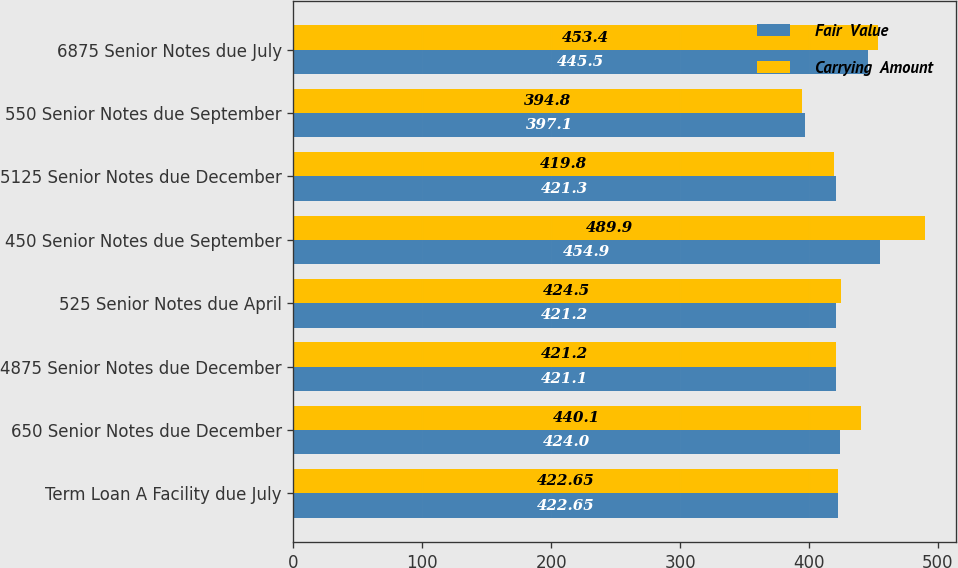Convert chart to OTSL. <chart><loc_0><loc_0><loc_500><loc_500><stacked_bar_chart><ecel><fcel>Term Loan A Facility due July<fcel>650 Senior Notes due December<fcel>4875 Senior Notes due December<fcel>525 Senior Notes due April<fcel>450 Senior Notes due September<fcel>5125 Senior Notes due December<fcel>550 Senior Notes due September<fcel>6875 Senior Notes due July<nl><fcel>Fair  Value<fcel>422.65<fcel>424<fcel>421.1<fcel>421.2<fcel>454.9<fcel>421.3<fcel>397.1<fcel>445.5<nl><fcel>Carrying  Amount<fcel>422.65<fcel>440.1<fcel>421.2<fcel>424.5<fcel>489.9<fcel>419.8<fcel>394.8<fcel>453.4<nl></chart> 